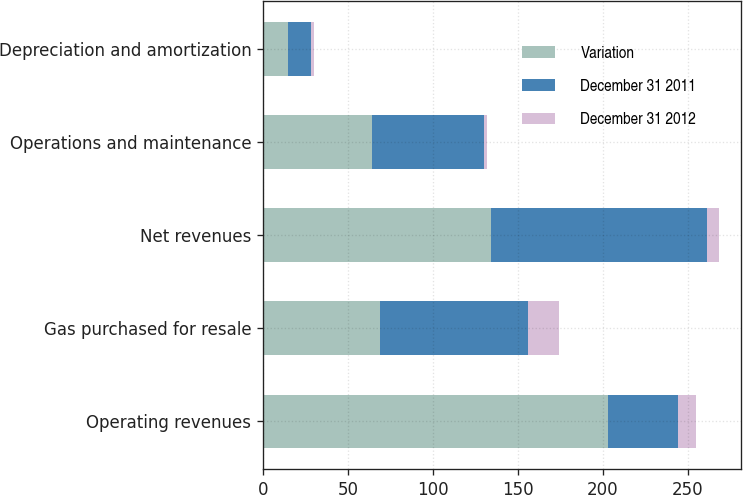Convert chart to OTSL. <chart><loc_0><loc_0><loc_500><loc_500><stacked_bar_chart><ecel><fcel>Operating revenues<fcel>Gas purchased for resale<fcel>Net revenues<fcel>Operations and maintenance<fcel>Depreciation and amortization<nl><fcel>Variation<fcel>203<fcel>69<fcel>134<fcel>64<fcel>15<nl><fcel>December 31 2011<fcel>41<fcel>87<fcel>127<fcel>66<fcel>13<nl><fcel>December 31 2012<fcel>11<fcel>18<fcel>7<fcel>2<fcel>2<nl></chart> 